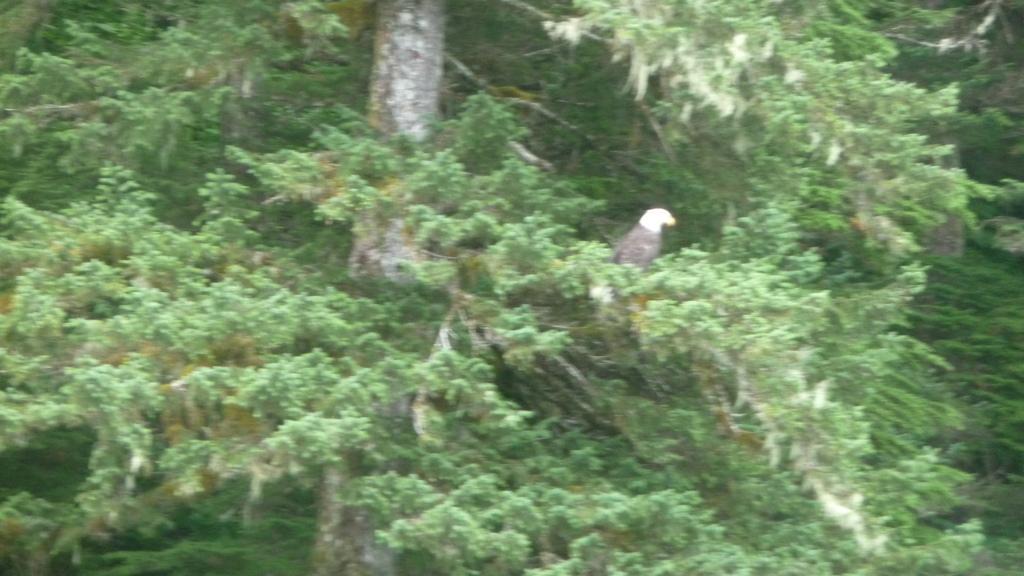Please provide a concise description of this image. In this picture we can see a bird on a tree. 